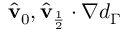Convert formula to latex. <formula><loc_0><loc_0><loc_500><loc_500>\hat { v } _ { 0 } , \hat { v } _ { \frac { 1 } { 2 } } \cdot \nabla d _ { \Gamma }</formula> 